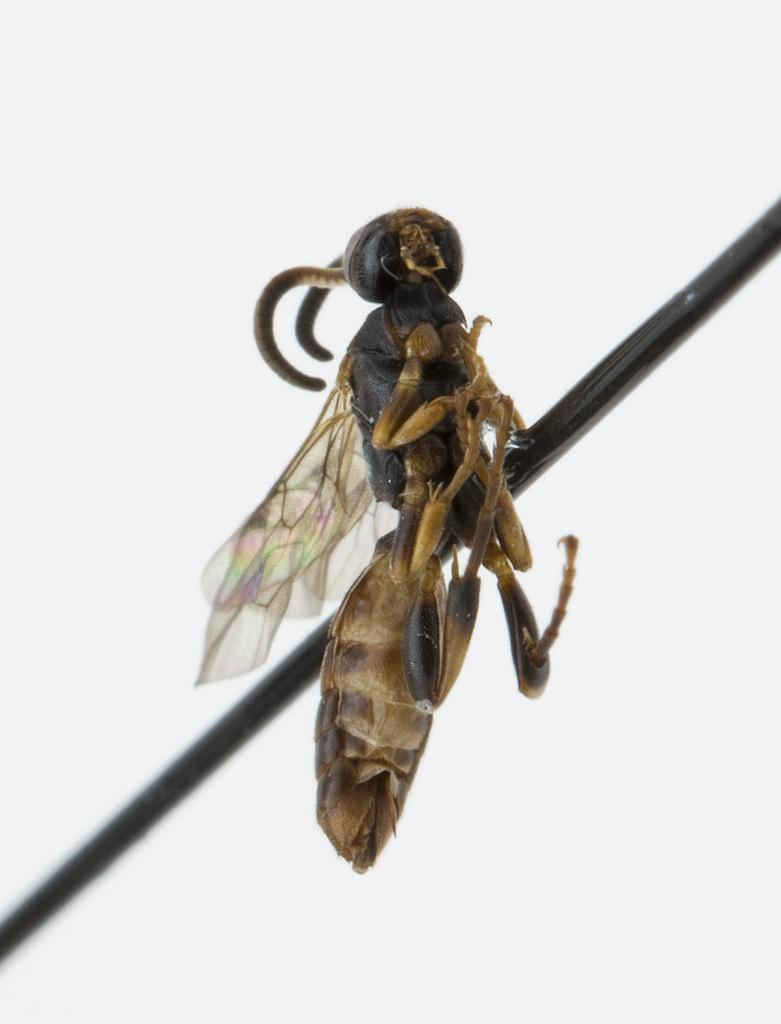Can you describe this image briefly? In the picture I can see the hornet insect. 